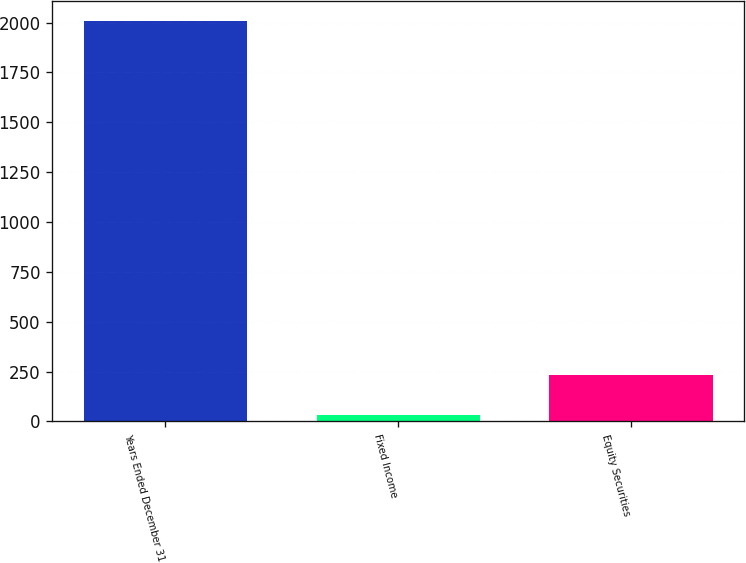Convert chart. <chart><loc_0><loc_0><loc_500><loc_500><bar_chart><fcel>Years Ended December 31<fcel>Fixed Income<fcel>Equity Securities<nl><fcel>2007<fcel>34<fcel>231.3<nl></chart> 